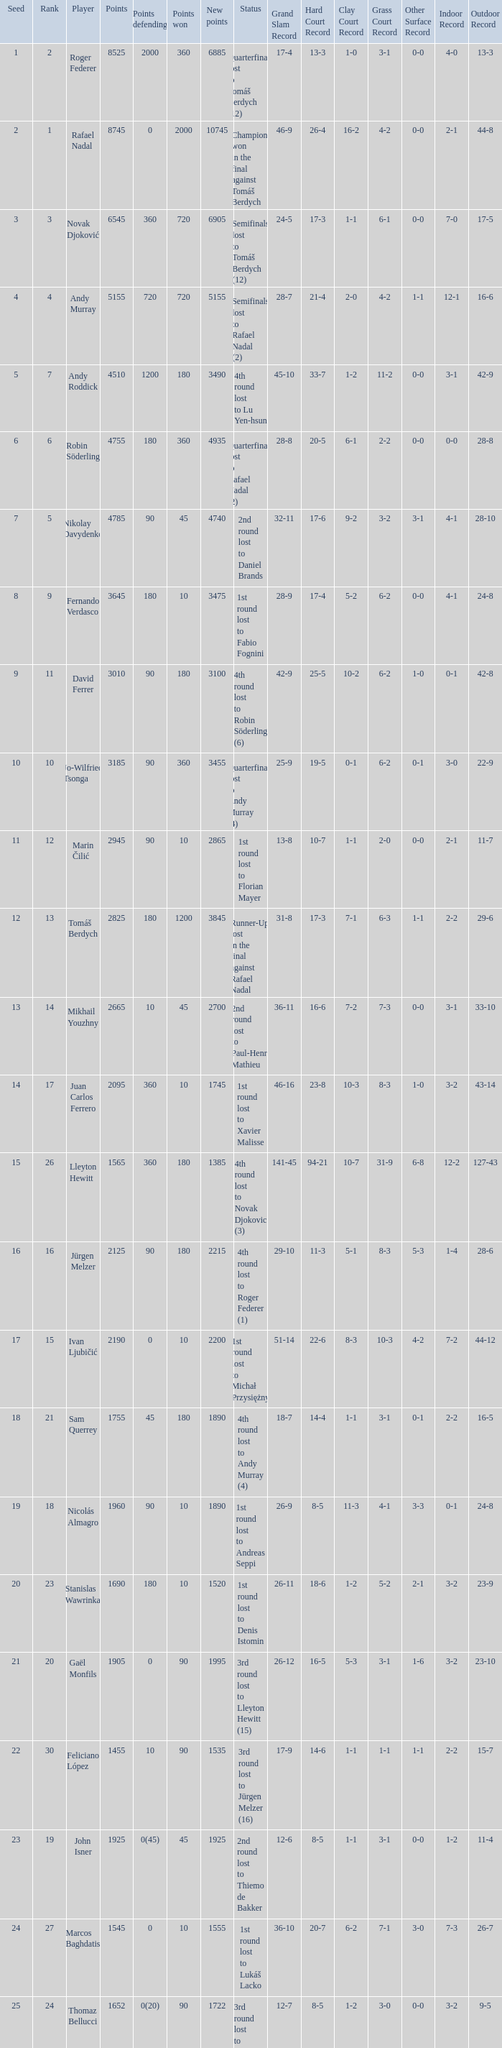Name the status for points 3185 Quarterfinals lost to Andy Murray (4). 